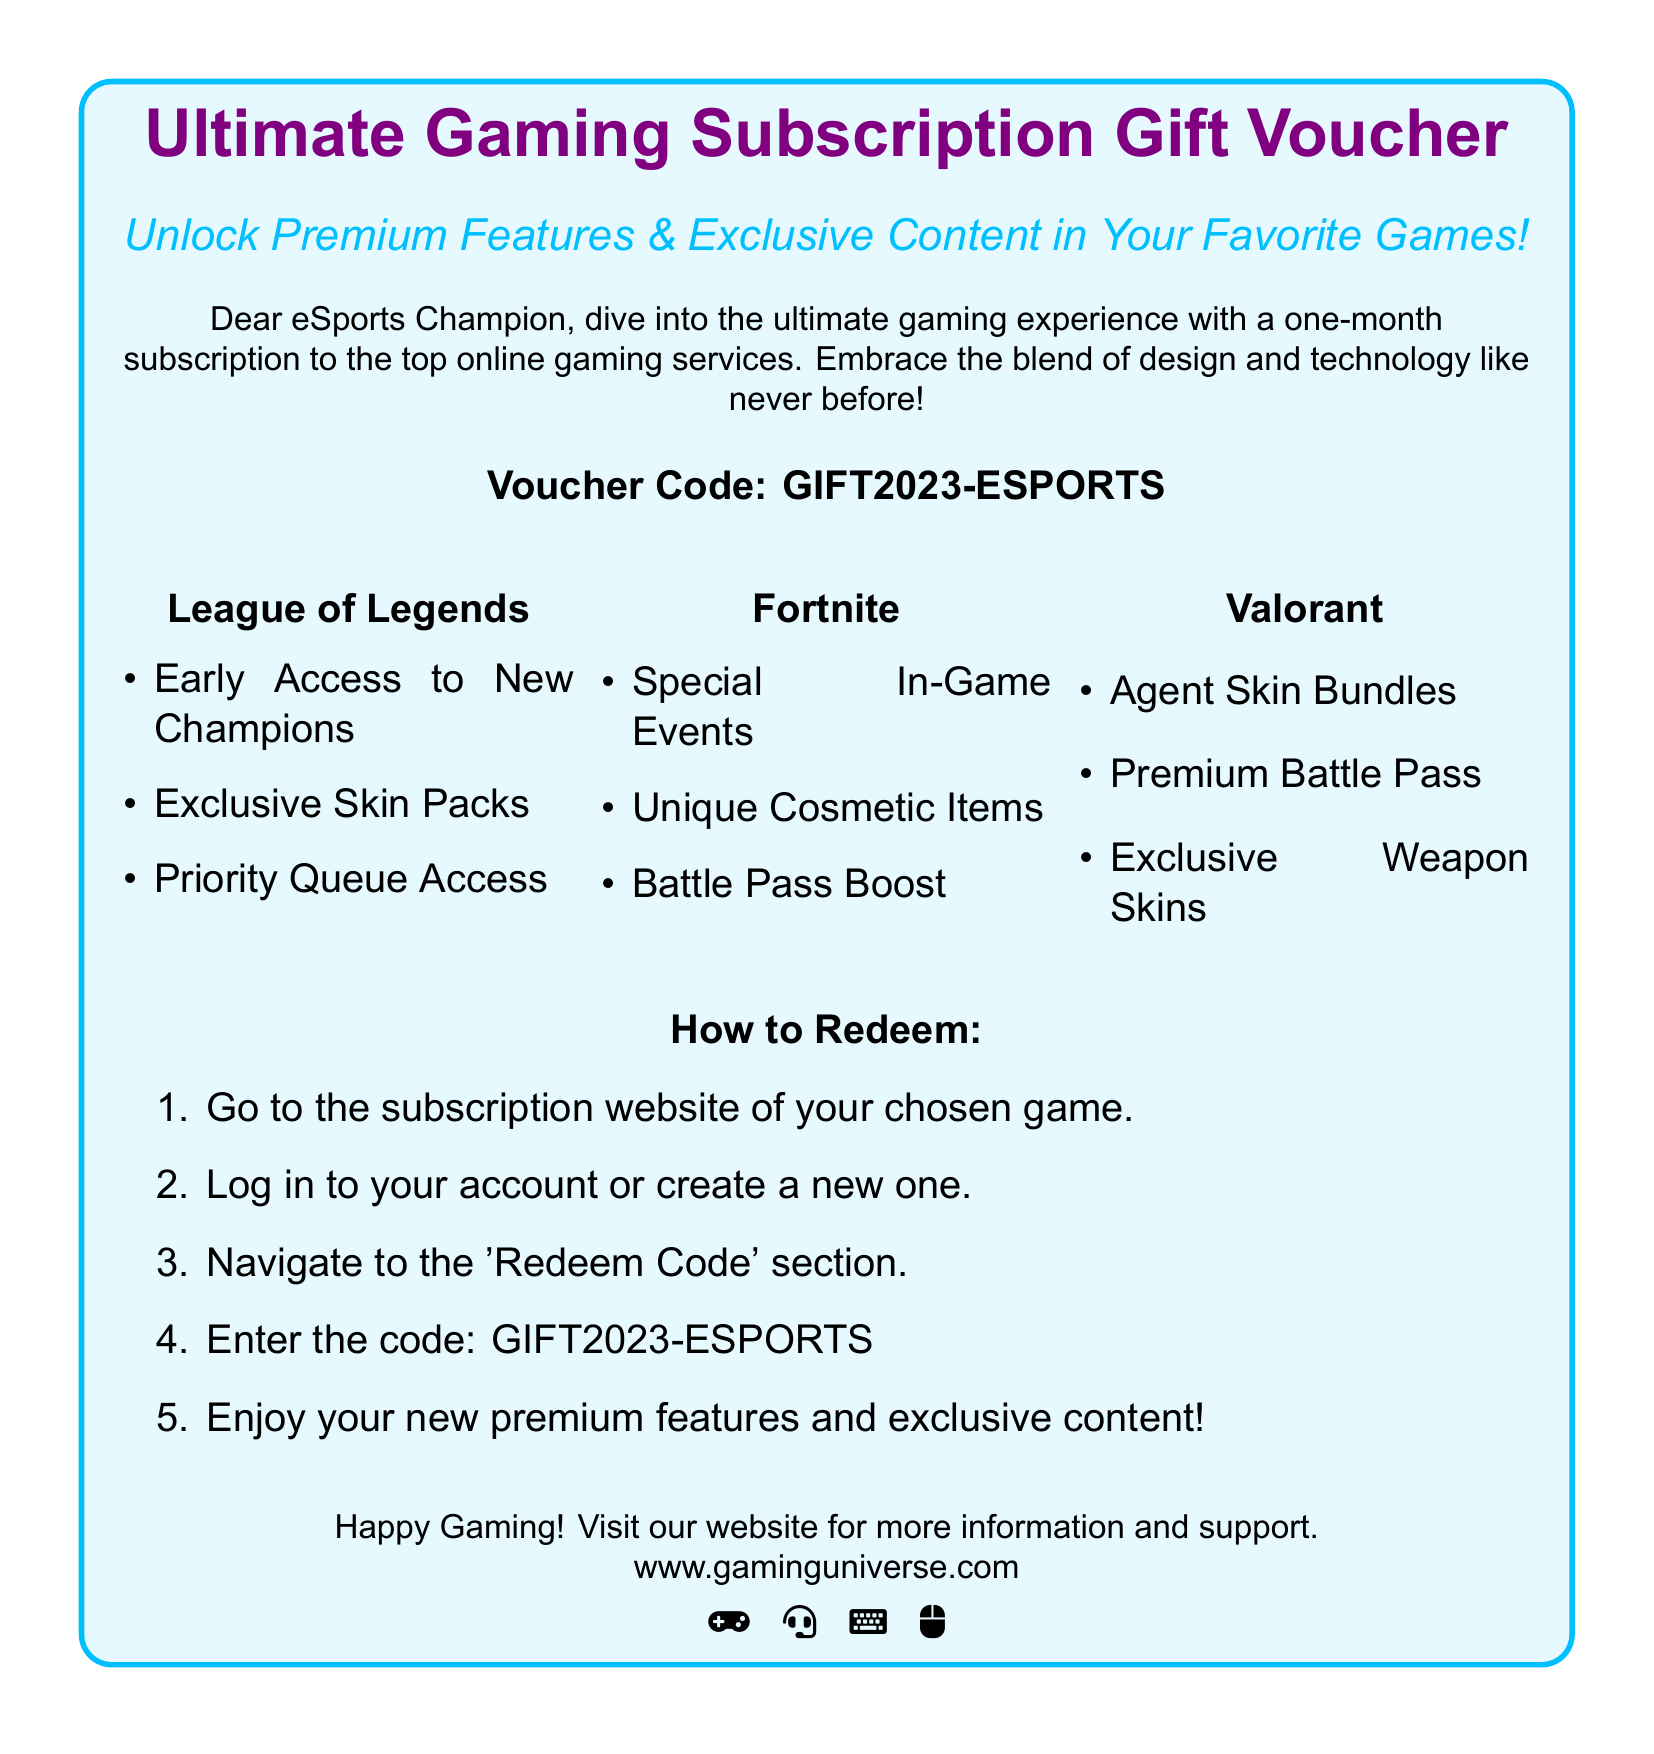What is the voucher code? The voucher code is provided in the document as a specific string that users can redeem for subscriptions.
Answer: GIFT2023-ESPORTS What month does the subscription last? The document specifies the duration of the subscription, which is clearly mentioned as one month.
Answer: One month Name one feature offered for League of Legends. The features listed under League of Legends indicate unique advantages for players.
Answer: Early Access to New Champions What type of events does the Fortnite offer? The document highlights specific offerings in the Fortnite section that enhance user engagement.
Answer: Special In-Game Events How do you redeem the voucher? The document provides a list of steps for redeeming the voucher, which users can follow.
Answer: Go to the subscription website What is the main purpose of this gift voucher? The main purpose of the voucher as presented in the document is clearly defined in the introductory statement.
Answer: Unlock Premium Features & Exclusive Content What should you do after logging into your account? The document outlines a series of actions that follow after logging in, creating a logical sequence for the user.
Answer: Navigate to the 'Redeem Code' section Which game has a Premium Battle Pass feature? The document categorizes the features by game, and one game specifically includes this feature.
Answer: Valorant What does the design of the document aim to convey? The design elements combined with text aim to create a thematic representation appealing to gamers and eSports champions.
Answer: Ultimate Gaming Experience 